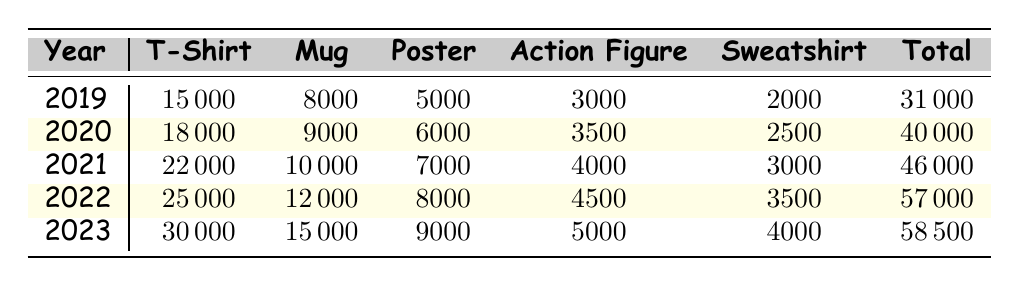What was the total merchandise sales in 2021? The total merchandise sales for the year 2021 can be found in the "Total" column corresponding to the year 2021. The value listed there is 46000.
Answer: 46000 What was the increase in T-shirt sales from 2019 to 2022? To find the increase in T-shirt sales from 2019 to 2022, we subtract the T-shirt sales in 2019 (15000) from the T-shirt sales in 2022 (25000). This results in 25000 - 15000 = 10000.
Answer: 10000 Did the sales of Action Figures increase every year? By reviewing the Action Figure sales for each year in the table, we see the following sales: 3000 (2019), 3500 (2020), 4000 (2021), 4500 (2022), and 5000 (2023). Each value is greater than the previous year, indicating a consistent increase.
Answer: Yes What was the average sales number of Mugs over the five years? To calculate the average, we first sum the Mug sales for all years: 8000 + 9000 + 10000 + 12000 + 15000 = 63000. We then divide this sum by the number of years, which is 5. Hence, the average sales number of Mugs is 63000 / 5 = 12600.
Answer: 12600 In which year did Poster sales hit their highest point, and what was that figure? Reviewing the Poster sales data: 5000 (2019), 6000 (2020), 7000 (2021), 8000 (2022), and 9000 (2023), the highest point occurs in 2023 at 9000 sales.
Answer: 2023, 9000 What was the total sales for the year with the lowest sales? The sales data indicates that 2019 had the lowest total sales figure of 31000. Therefore, the total sales for that year is the answer.
Answer: 31000 How much more did sweatshirt sales increase in 2023 compared to 2020? The sweatshirt sales for 2023 are 4000, and for 2020 they are 2500. Subtracting the lower figure from the higher gives 4000 - 2500 = 1500, which shows the increase.
Answer: 1500 What percentage of the total sales in 2022 came from T-shirt sales? T-shirt sales in 2022 were 25000, while total sales that year were 57000. To find the percentage contribution, we can divide the T-shirt sales by total sales and multiply by 100: (25000 / 57000) * 100 ≈ 43.86%.
Answer: Approximately 43.86% 